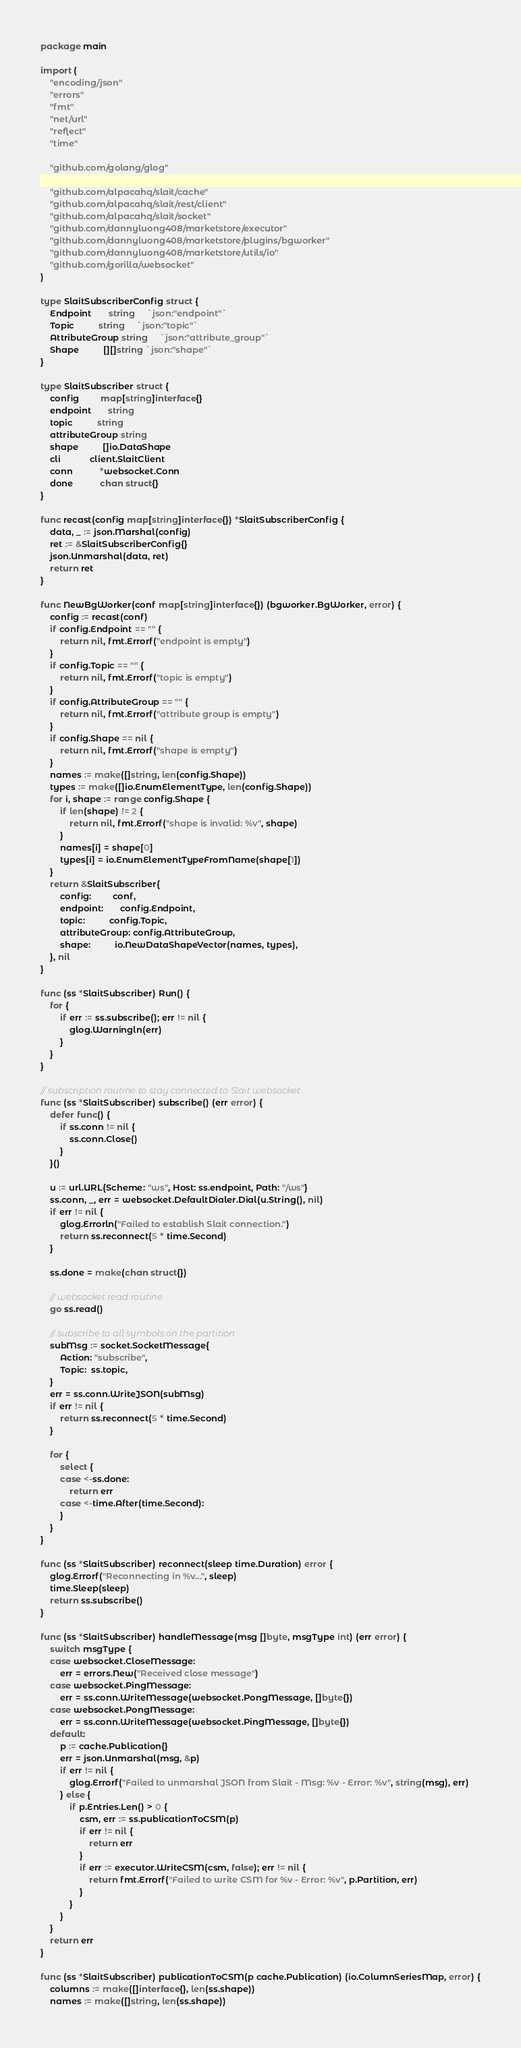Convert code to text. <code><loc_0><loc_0><loc_500><loc_500><_Go_>package main

import (
	"encoding/json"
	"errors"
	"fmt"
	"net/url"
	"reflect"
	"time"

	"github.com/golang/glog"

	"github.com/alpacahq/slait/cache"
	"github.com/alpacahq/slait/rest/client"
	"github.com/alpacahq/slait/socket"
	"github.com/dannyluong408/marketstore/executor"
	"github.com/dannyluong408/marketstore/plugins/bgworker"
	"github.com/dannyluong408/marketstore/utils/io"
	"github.com/gorilla/websocket"
)

type SlaitSubscriberConfig struct {
	Endpoint       string     `json:"endpoint"`
	Topic          string     `json:"topic"`
	AttributeGroup string     `json:"attribute_group"`
	Shape          [][]string `json:"shape"`
}

type SlaitSubscriber struct {
	config         map[string]interface{}
	endpoint       string
	topic          string
	attributeGroup string
	shape          []io.DataShape
	cli            client.SlaitClient
	conn           *websocket.Conn
	done           chan struct{}
}

func recast(config map[string]interface{}) *SlaitSubscriberConfig {
	data, _ := json.Marshal(config)
	ret := &SlaitSubscriberConfig{}
	json.Unmarshal(data, ret)
	return ret
}

func NewBgWorker(conf map[string]interface{}) (bgworker.BgWorker, error) {
	config := recast(conf)
	if config.Endpoint == "" {
		return nil, fmt.Errorf("endpoint is empty")
	}
	if config.Topic == "" {
		return nil, fmt.Errorf("topic is empty")
	}
	if config.AttributeGroup == "" {
		return nil, fmt.Errorf("attribute group is empty")
	}
	if config.Shape == nil {
		return nil, fmt.Errorf("shape is empty")
	}
	names := make([]string, len(config.Shape))
	types := make([]io.EnumElementType, len(config.Shape))
	for i, shape := range config.Shape {
		if len(shape) != 2 {
			return nil, fmt.Errorf("shape is invalid: %v", shape)
		}
		names[i] = shape[0]
		types[i] = io.EnumElementTypeFromName(shape[1])
	}
	return &SlaitSubscriber{
		config:         conf,
		endpoint:       config.Endpoint,
		topic:          config.Topic,
		attributeGroup: config.AttributeGroup,
		shape:          io.NewDataShapeVector(names, types),
	}, nil
}

func (ss *SlaitSubscriber) Run() {
	for {
		if err := ss.subscribe(); err != nil {
			glog.Warningln(err)
		}
	}
}

// subscription routine to stay connected to Slait websocket
func (ss *SlaitSubscriber) subscribe() (err error) {
	defer func() {
		if ss.conn != nil {
			ss.conn.Close()
		}
	}()

	u := url.URL{Scheme: "ws", Host: ss.endpoint, Path: "/ws"}
	ss.conn, _, err = websocket.DefaultDialer.Dial(u.String(), nil)
	if err != nil {
		glog.Errorln("Failed to establish Slait connection.")
		return ss.reconnect(5 * time.Second)
	}

	ss.done = make(chan struct{})

	// websocket read routine
	go ss.read()

	// subscribe to all symbols on the partition
	subMsg := socket.SocketMessage{
		Action: "subscribe",
		Topic:  ss.topic,
	}
	err = ss.conn.WriteJSON(subMsg)
	if err != nil {
		return ss.reconnect(5 * time.Second)
	}

	for {
		select {
		case <-ss.done:
			return err
		case <-time.After(time.Second):
		}
	}
}

func (ss *SlaitSubscriber) reconnect(sleep time.Duration) error {
	glog.Errorf("Reconnecting in %v...", sleep)
	time.Sleep(sleep)
	return ss.subscribe()
}

func (ss *SlaitSubscriber) handleMessage(msg []byte, msgType int) (err error) {
	switch msgType {
	case websocket.CloseMessage:
		err = errors.New("Received close message")
	case websocket.PingMessage:
		err = ss.conn.WriteMessage(websocket.PongMessage, []byte{})
	case websocket.PongMessage:
		err = ss.conn.WriteMessage(websocket.PingMessage, []byte{})
	default:
		p := cache.Publication{}
		err = json.Unmarshal(msg, &p)
		if err != nil {
			glog.Errorf("Failed to unmarshal JSON from Slait - Msg: %v - Error: %v", string(msg), err)
		} else {
			if p.Entries.Len() > 0 {
				csm, err := ss.publicationToCSM(p)
				if err != nil {
					return err
				}
				if err := executor.WriteCSM(csm, false); err != nil {
					return fmt.Errorf("Failed to write CSM for %v - Error: %v", p.Partition, err)
				}
			}
		}
	}
	return err
}

func (ss *SlaitSubscriber) publicationToCSM(p cache.Publication) (io.ColumnSeriesMap, error) {
	columns := make([]interface{}, len(ss.shape))
	names := make([]string, len(ss.shape))</code> 